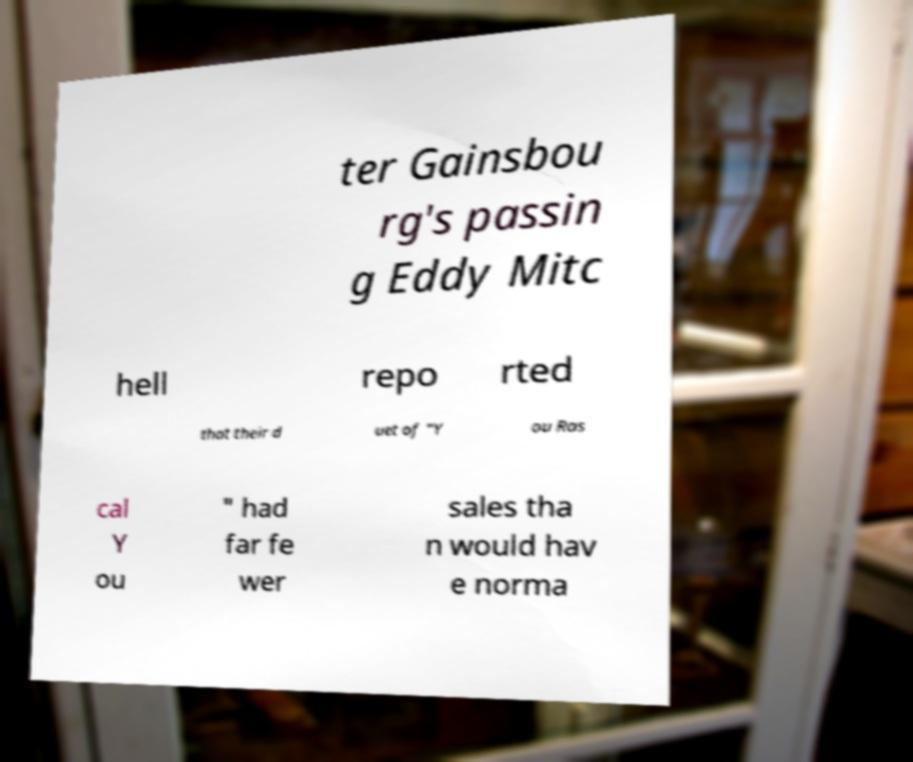Can you accurately transcribe the text from the provided image for me? ter Gainsbou rg's passin g Eddy Mitc hell repo rted that their d uet of "Y ou Ras cal Y ou " had far fe wer sales tha n would hav e norma 